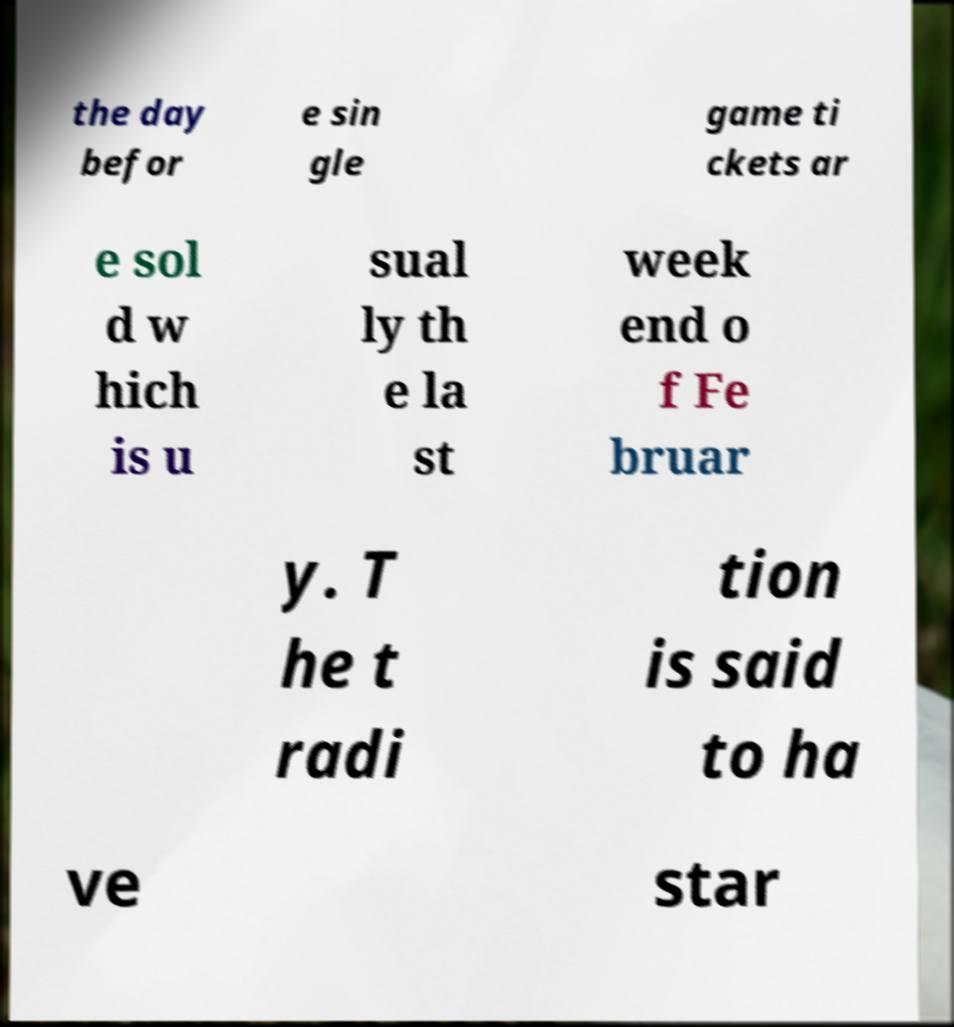Please read and relay the text visible in this image. What does it say? the day befor e sin gle game ti ckets ar e sol d w hich is u sual ly th e la st week end o f Fe bruar y. T he t radi tion is said to ha ve star 